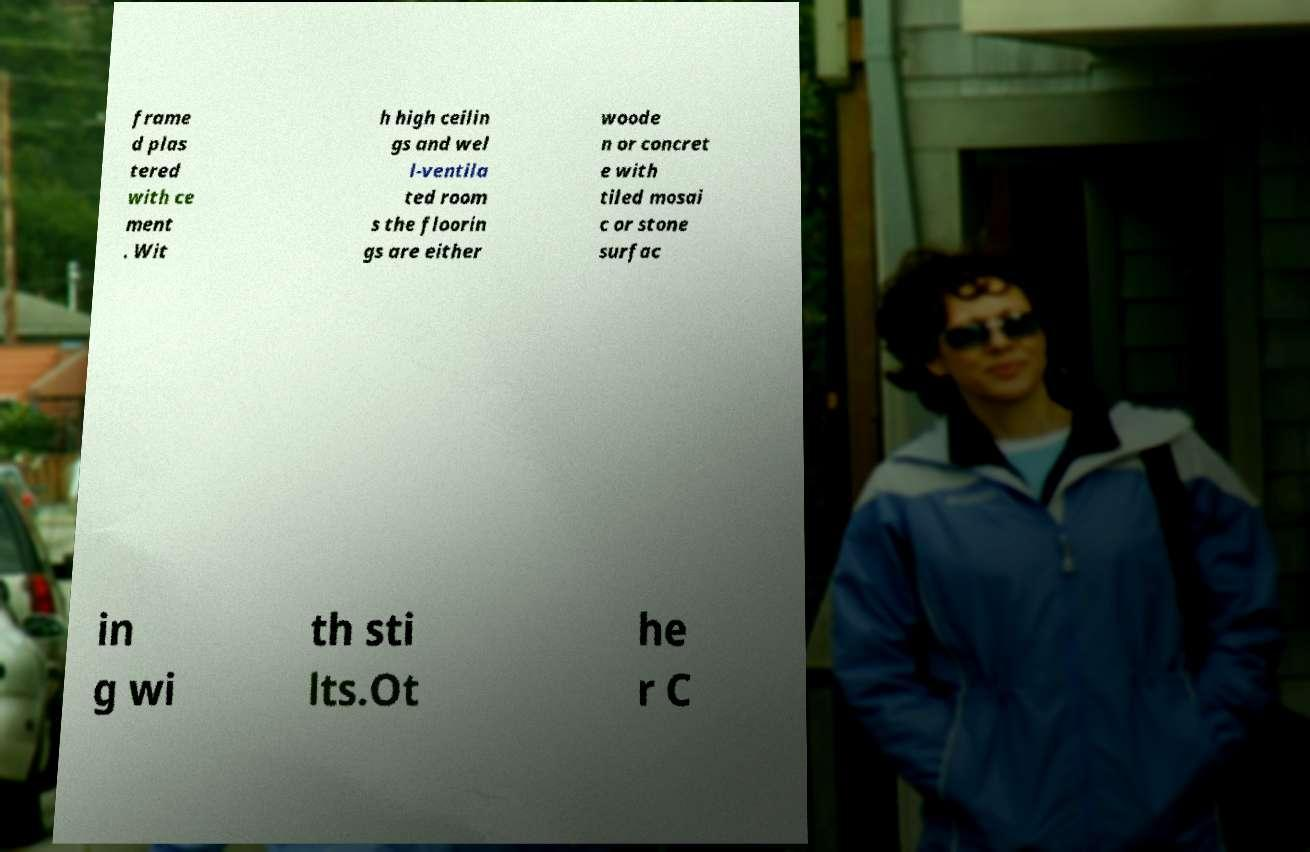Can you read and provide the text displayed in the image?This photo seems to have some interesting text. Can you extract and type it out for me? frame d plas tered with ce ment . Wit h high ceilin gs and wel l-ventila ted room s the floorin gs are either woode n or concret e with tiled mosai c or stone surfac in g wi th sti lts.Ot he r C 